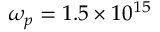Convert formula to latex. <formula><loc_0><loc_0><loc_500><loc_500>\omega _ { p } = 1 . 5 \times 1 0 ^ { 1 5 }</formula> 